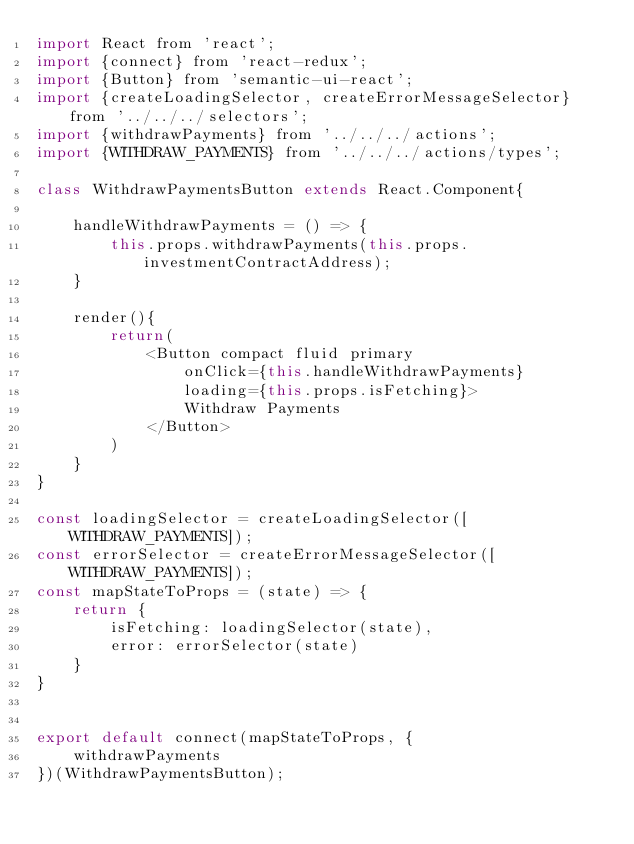Convert code to text. <code><loc_0><loc_0><loc_500><loc_500><_JavaScript_>import React from 'react';
import {connect} from 'react-redux';
import {Button} from 'semantic-ui-react';
import {createLoadingSelector, createErrorMessageSelector} from '../../../selectors';
import {withdrawPayments} from '../../../actions';
import {WITHDRAW_PAYMENTS} from '../../../actions/types';

class WithdrawPaymentsButton extends React.Component{

    handleWithdrawPayments = () => {
        this.props.withdrawPayments(this.props.investmentContractAddress);
    }

    render(){
        return(
            <Button compact fluid primary 
                onClick={this.handleWithdrawPayments} 
                loading={this.props.isFetching}>
                Withdraw Payments
            </Button>
        )
    }
}

const loadingSelector = createLoadingSelector([WITHDRAW_PAYMENTS]);
const errorSelector = createErrorMessageSelector([WITHDRAW_PAYMENTS]);
const mapStateToProps = (state) => {
    return {
        isFetching: loadingSelector(state),
        error: errorSelector(state)
    }
}


export default connect(mapStateToProps, {
    withdrawPayments
})(WithdrawPaymentsButton);

</code> 